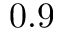<formula> <loc_0><loc_0><loc_500><loc_500>0 . 9</formula> 